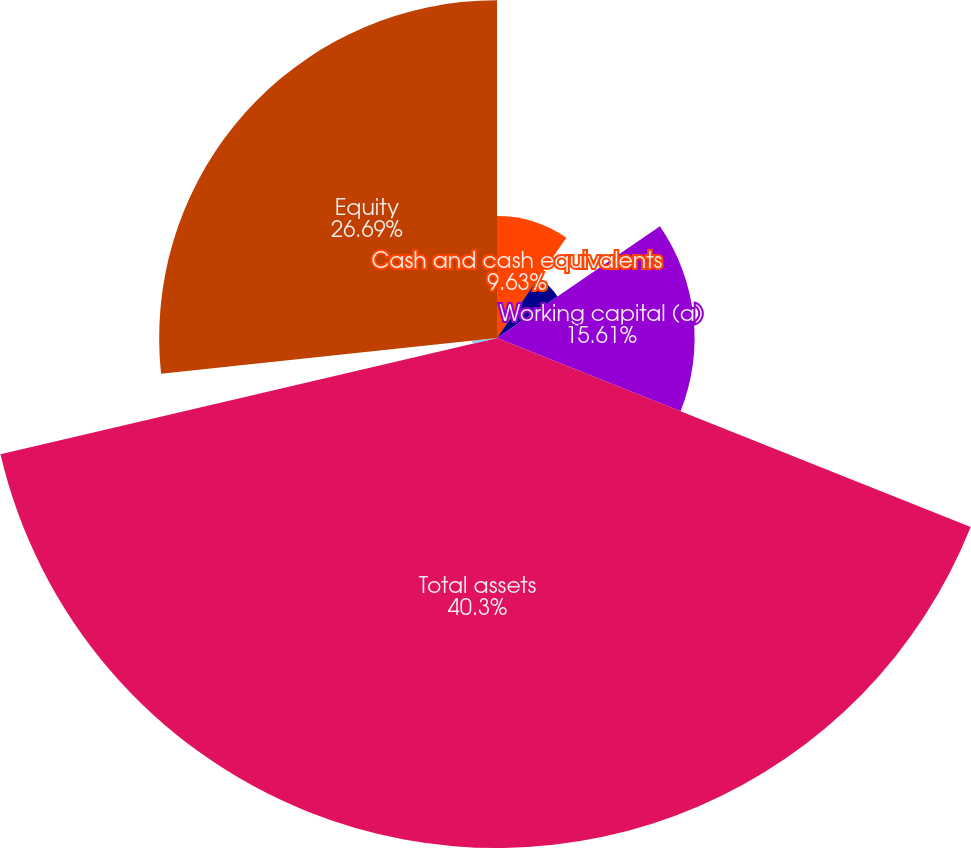Convert chart to OTSL. <chart><loc_0><loc_0><loc_500><loc_500><pie_chart><fcel>Cash and cash equivalents<fcel>Investments<fcel>Working capital (a)<fcel>Total assets<fcel>Total debt (including current<fcel>Equity<nl><fcel>9.63%<fcel>5.8%<fcel>15.61%<fcel>40.29%<fcel>1.97%<fcel>26.69%<nl></chart> 